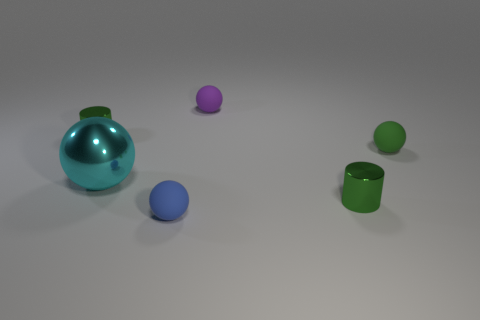Add 2 purple objects. How many objects exist? 8 Subtract all matte spheres. How many spheres are left? 1 Subtract all cylinders. How many objects are left? 4 Subtract all cyan blocks. How many purple spheres are left? 1 Subtract all large metallic spheres. Subtract all large cyan metal spheres. How many objects are left? 4 Add 1 tiny green rubber balls. How many tiny green rubber balls are left? 2 Add 6 small balls. How many small balls exist? 9 Subtract all cyan spheres. How many spheres are left? 3 Subtract 0 blue cylinders. How many objects are left? 6 Subtract 4 balls. How many balls are left? 0 